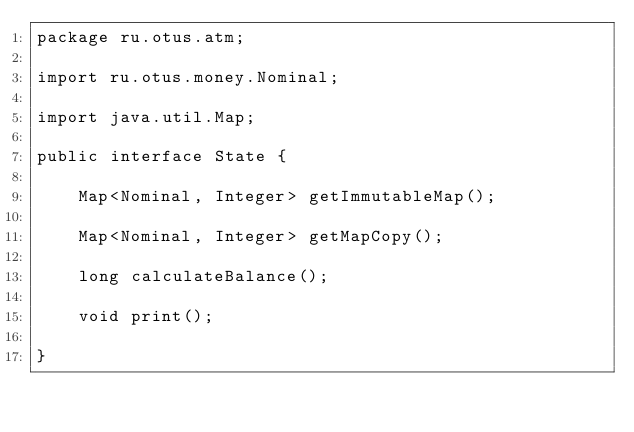<code> <loc_0><loc_0><loc_500><loc_500><_Java_>package ru.otus.atm;

import ru.otus.money.Nominal;

import java.util.Map;

public interface State {

    Map<Nominal, Integer> getImmutableMap();

    Map<Nominal, Integer> getMapCopy();

    long calculateBalance();

    void print();

}
</code> 